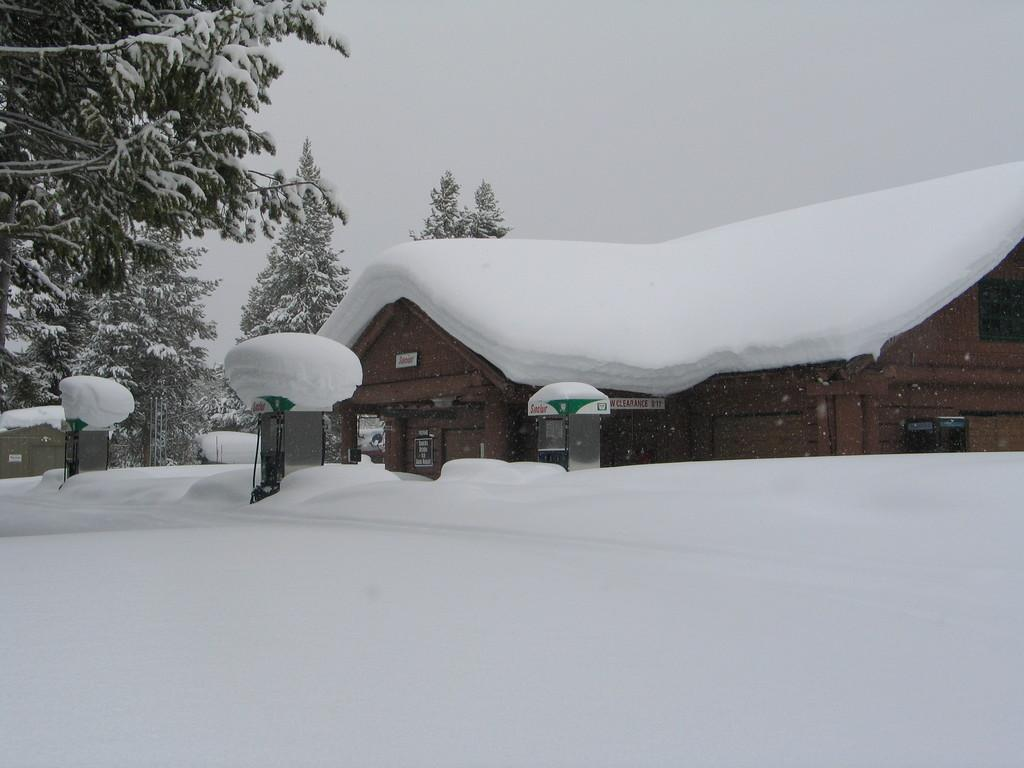What is the predominant weather condition in the image? There is snow in the image, indicating a cold and wintry condition. What objects can be seen in the image besides the snow? There are boxes, boards, a house, and trees visible in the image. Can you describe the house in the image? The house is a structure that can be seen in the image. What is visible in the background of the image? The sky is visible in the background of the image. What type of food is being prepared in the image? There is no food preparation visible in the image; it primarily features snow, boxes, boards, a house, trees, and the sky. How many ladybugs can be seen in the image? There are no ladybugs present in the image. 